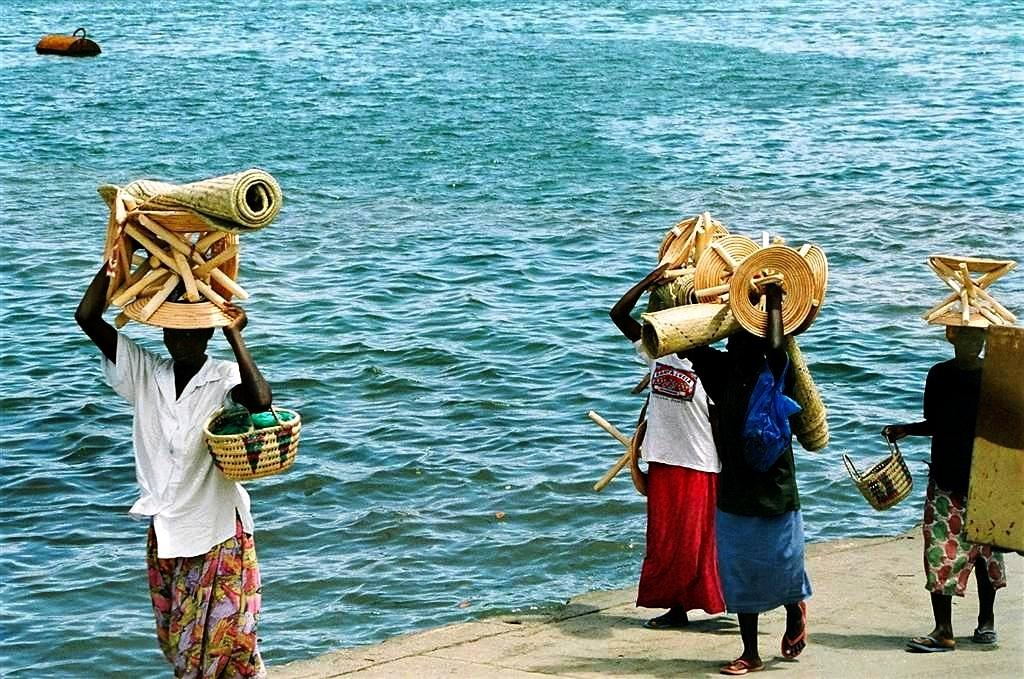How many people are in the image? There are four persons in the image. What are the persons holding in the image? The persons are standing and holding baskets, mats, and other objects. Can you describe the background of the image? There is an object floating on the water in the background of the image. What type of soap is being sold at the store in the image? There is no store present in the image, and therefore no soap being sold. How many ants can be seen crawling on the persons in the image? There are no ants visible in the image. 